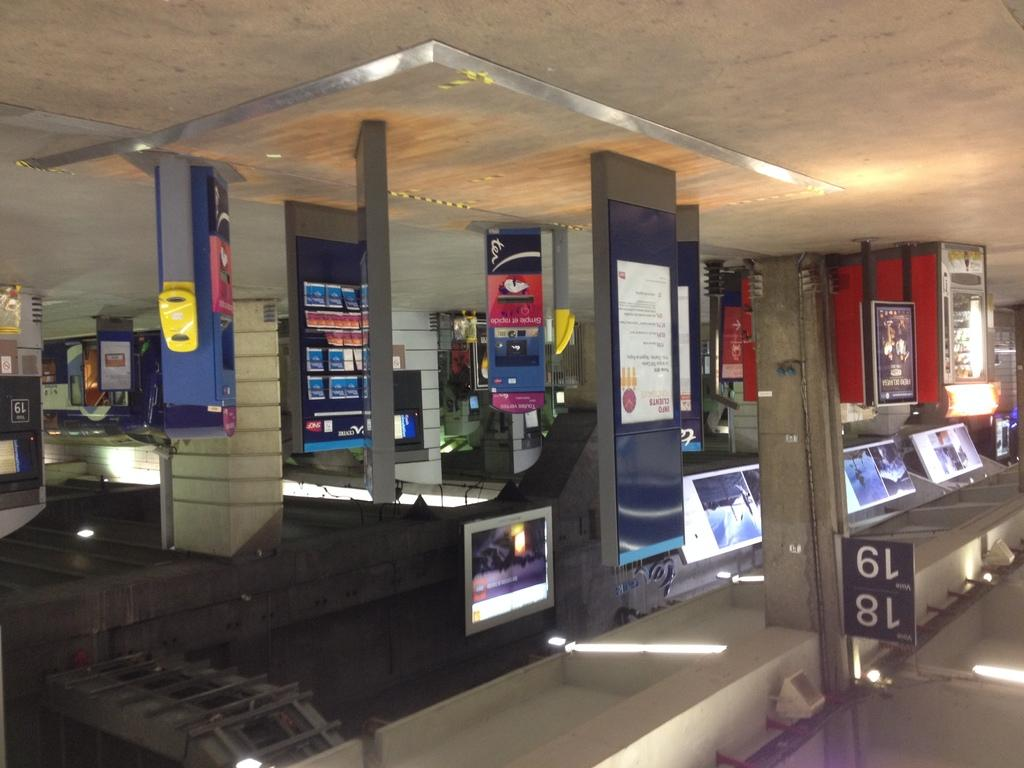<image>
Give a short and clear explanation of the subsequent image. Aisles 18 and 19 in an electronics store. 